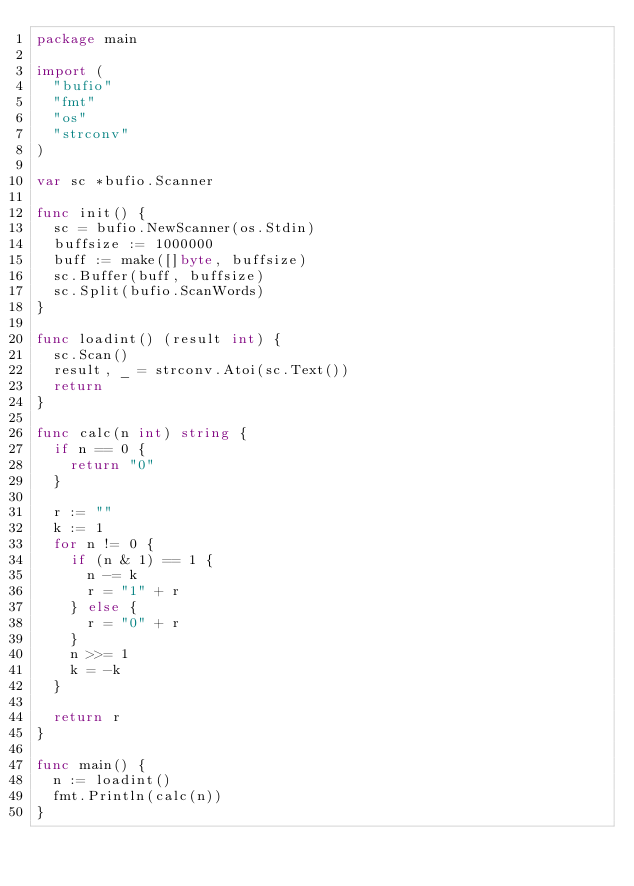Convert code to text. <code><loc_0><loc_0><loc_500><loc_500><_Go_>package main

import (
	"bufio"
	"fmt"
	"os"
	"strconv"
)

var sc *bufio.Scanner

func init() {
	sc = bufio.NewScanner(os.Stdin)
	buffsize := 1000000
	buff := make([]byte, buffsize)
	sc.Buffer(buff, buffsize)
	sc.Split(bufio.ScanWords)
}

func loadint() (result int) {
	sc.Scan()
	result, _ = strconv.Atoi(sc.Text())
	return
}

func calc(n int) string {
	if n == 0 {
		return "0"
	}

	r := ""
	k := 1
	for n != 0 {
		if (n & 1) == 1 {
			n -= k
			r = "1" + r
		} else {
			r = "0" + r
		}
		n >>= 1
		k = -k
	}

	return r
}

func main() {
	n := loadint()
	fmt.Println(calc(n))
}
</code> 